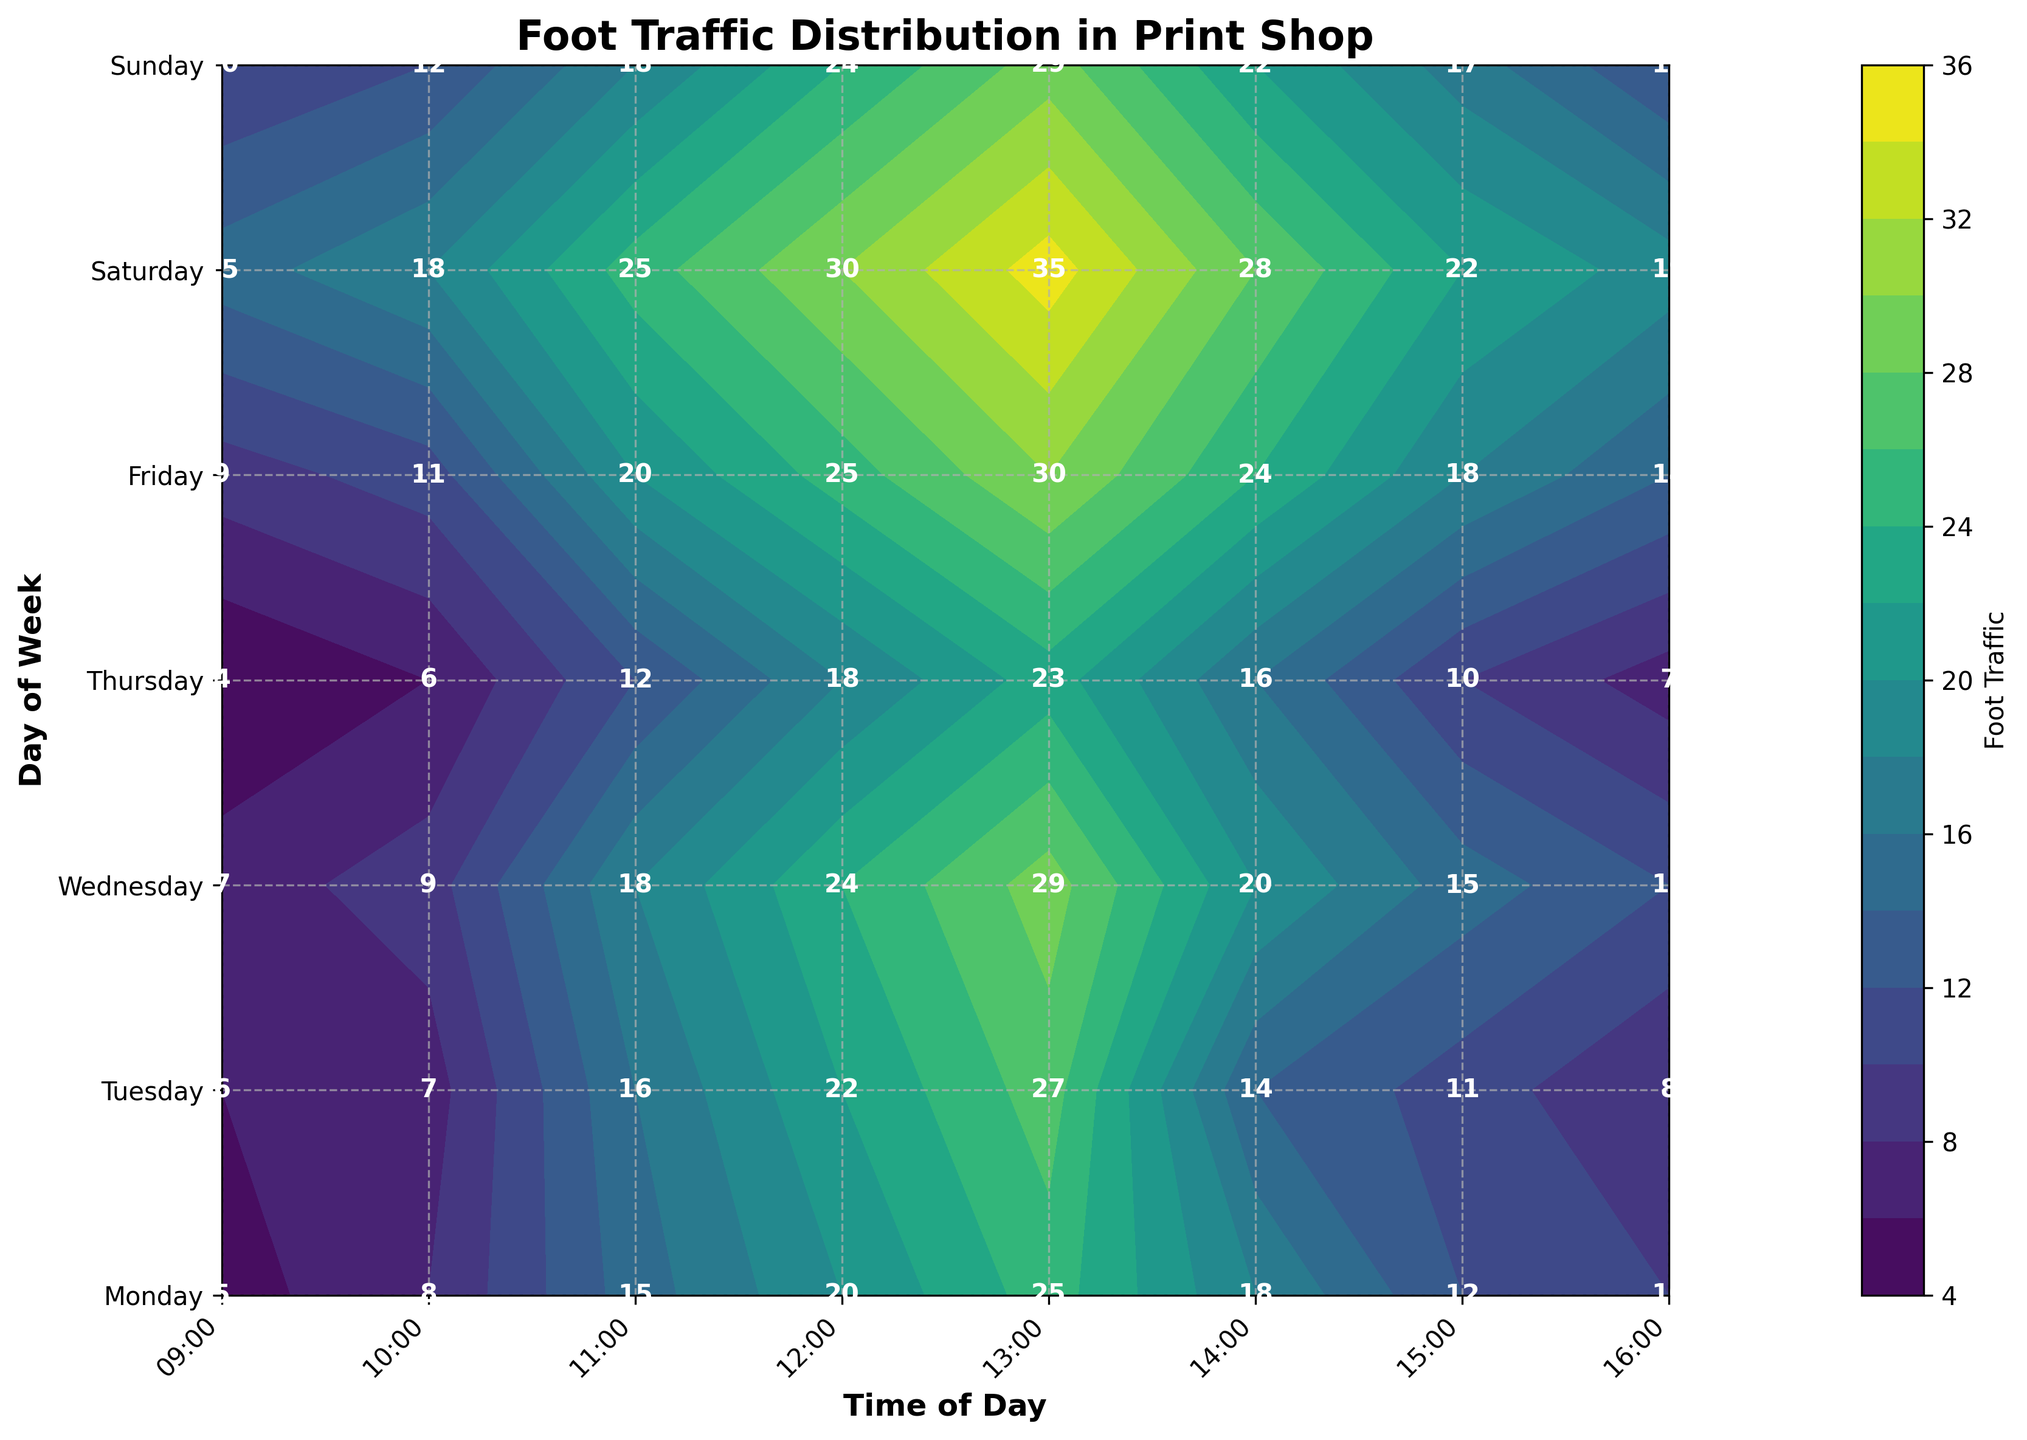What's the title of the figure? The title of a figure is usually displayed at the top. In this case, it's shown in the plotted figure.
Answer: Foot Traffic Distribution in Print Shop What does the color bar represent? A color bar on a contour plot usually indicates the range and meaning of the colors used in the plot. Here, the color bar represents the level of foot traffic.
Answer: Foot Traffic Which day of the week has the highest foot traffic at 13:00? Locate the 13:00 column on the x-axis and check the corresponding highest value along the y-axis (days of the week). The highest value can be observed at 13:00 on Saturday.
Answer: Saturday How does the foot traffic at 12:00 compare between Monday and Friday? Locate the 12:00 column and compare the values for Monday (top row) and Friday (fifth row). Monday has a foot traffic of 20, while Friday has a foot traffic of 25.
Answer: Friday has higher traffic Which day shows the lowest foot traffic at 9:00 AM? Look at the 9:00 column and identify the smallest value along the days of the week (y-axis). It is 4, which corresponds to Thursday.
Answer: Thursday What is the average foot traffic at 14:00 for the entire week? Find the foot traffic values at 14:00 for each day, sum them up (18 + 14 + 20 + 16 + 24 + 28 + 22 = 142), and then divide by the number of days (142 / 7).
Answer: 20.29 What trend, if any, can be observed in foot traffic from 09:00 to 16:00 on Saturday? Observe the values from 09:00 to 16:00 on Saturday. The trend shows increasing foot traffic from 09:00 (15) to 13:00 (35), and then a gradual decrease until 16:00 (19).
Answer: Increases then decreases During which time slot is the foot traffic consistently increasing for all weekdays? Examine each time slot from 09:00 to 16:00 across all days from Monday to Friday, and find a period where foot traffic increases on each day. Foot traffic consistently increases from 09:00 to 13:00 for all weekdays.
Answer: 09:00 to 13:00 